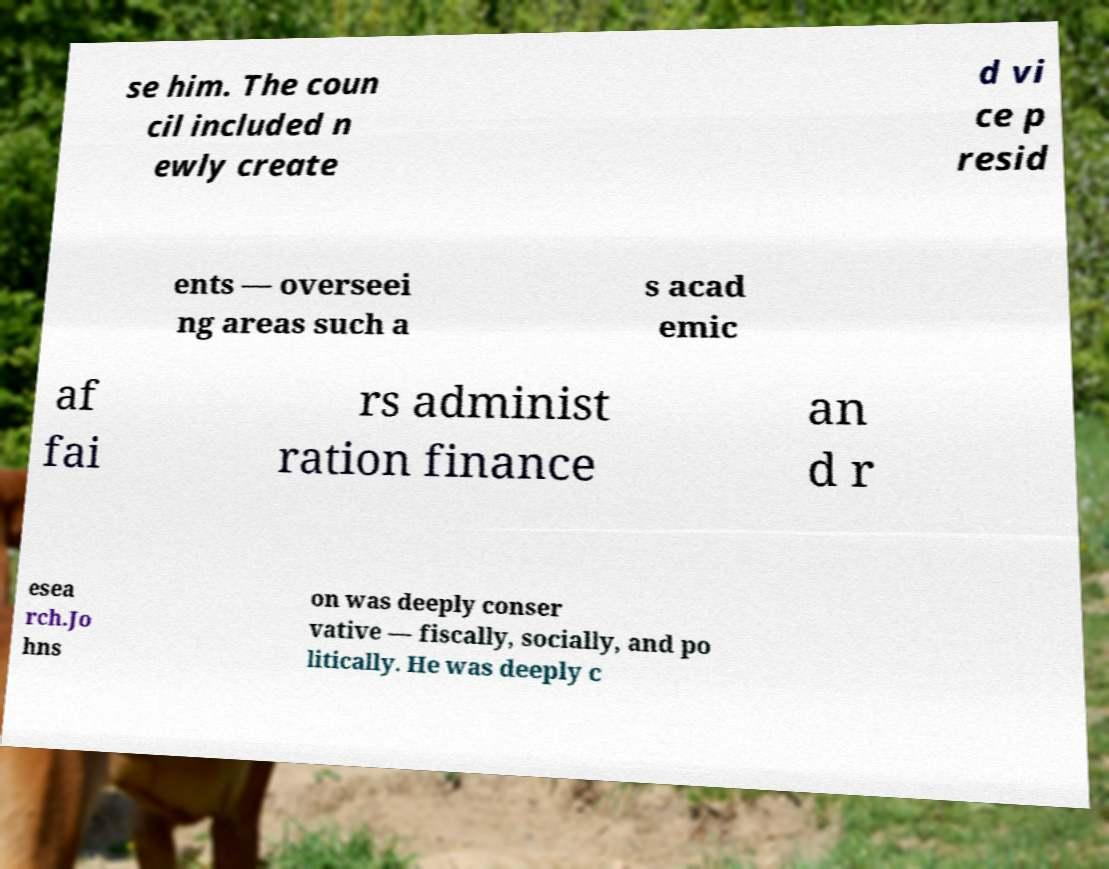Please read and relay the text visible in this image. What does it say? se him. The coun cil included n ewly create d vi ce p resid ents — overseei ng areas such a s acad emic af fai rs administ ration finance an d r esea rch.Jo hns on was deeply conser vative — fiscally, socially, and po litically. He was deeply c 